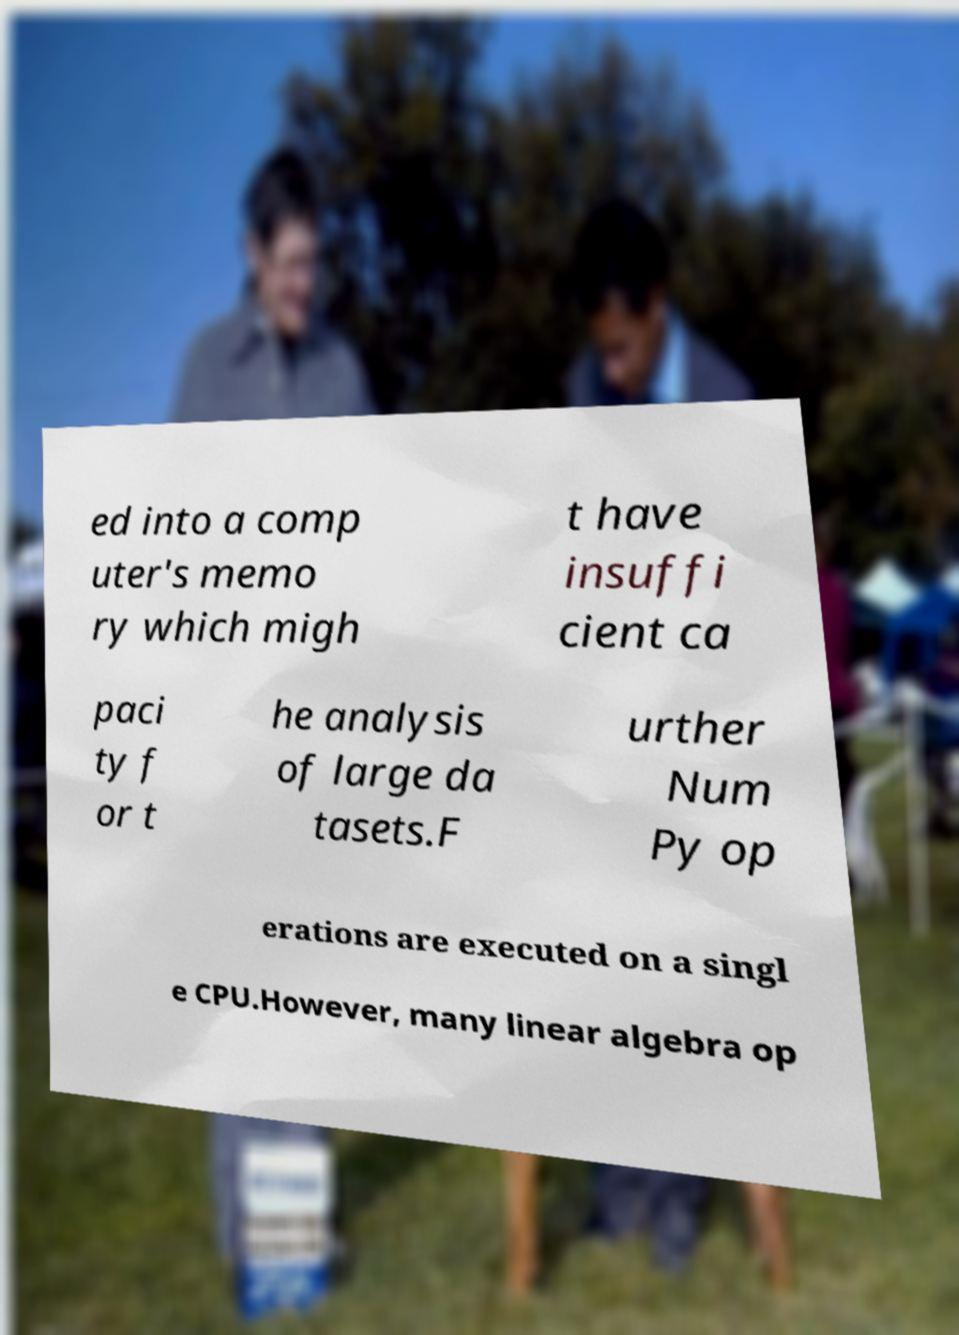Could you extract and type out the text from this image? ed into a comp uter's memo ry which migh t have insuffi cient ca paci ty f or t he analysis of large da tasets.F urther Num Py op erations are executed on a singl e CPU.However, many linear algebra op 